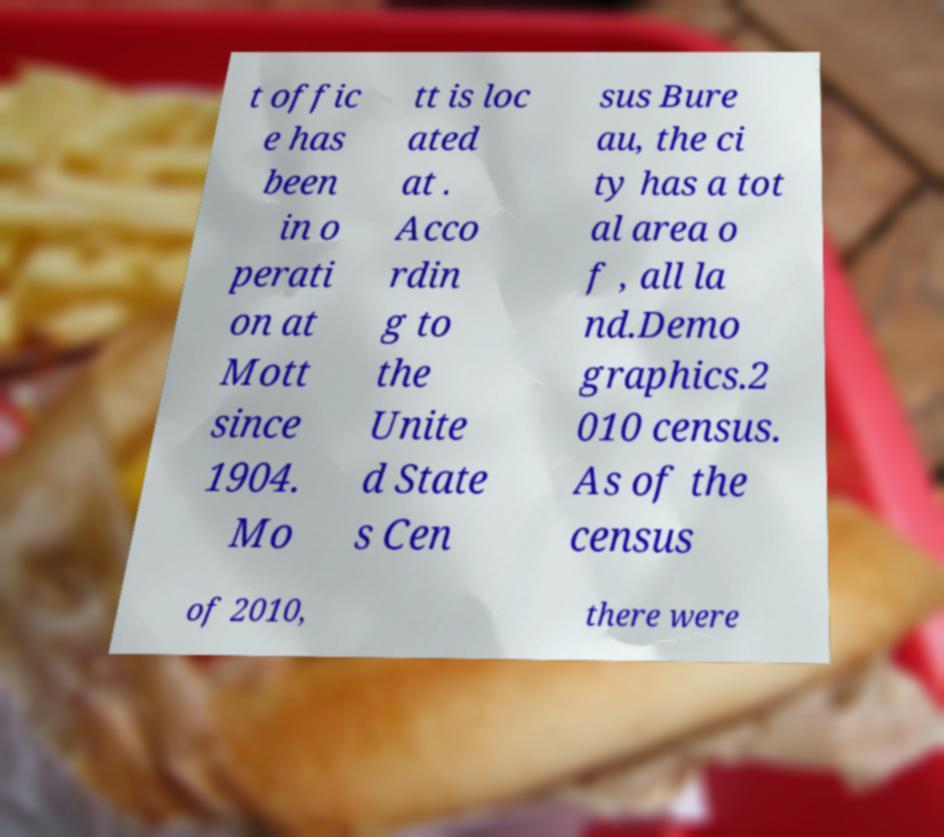Please identify and transcribe the text found in this image. t offic e has been in o perati on at Mott since 1904. Mo tt is loc ated at . Acco rdin g to the Unite d State s Cen sus Bure au, the ci ty has a tot al area o f , all la nd.Demo graphics.2 010 census. As of the census of 2010, there were 